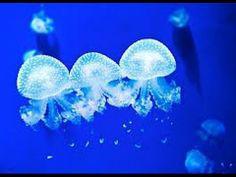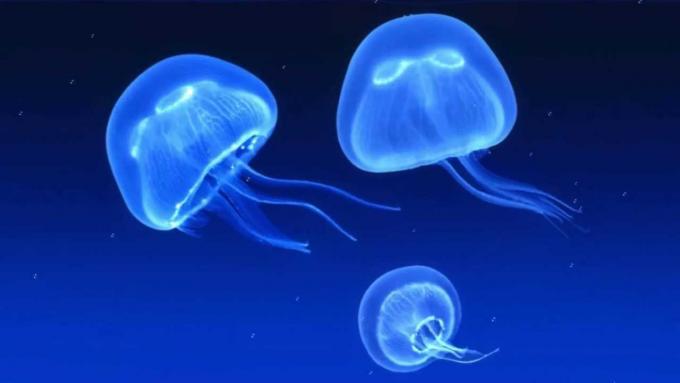The first image is the image on the left, the second image is the image on the right. For the images shown, is this caption "In the image on the right, exactly 2  jellyfish are floating  above 1 smaller jellyfish." true? Answer yes or no. Yes. 